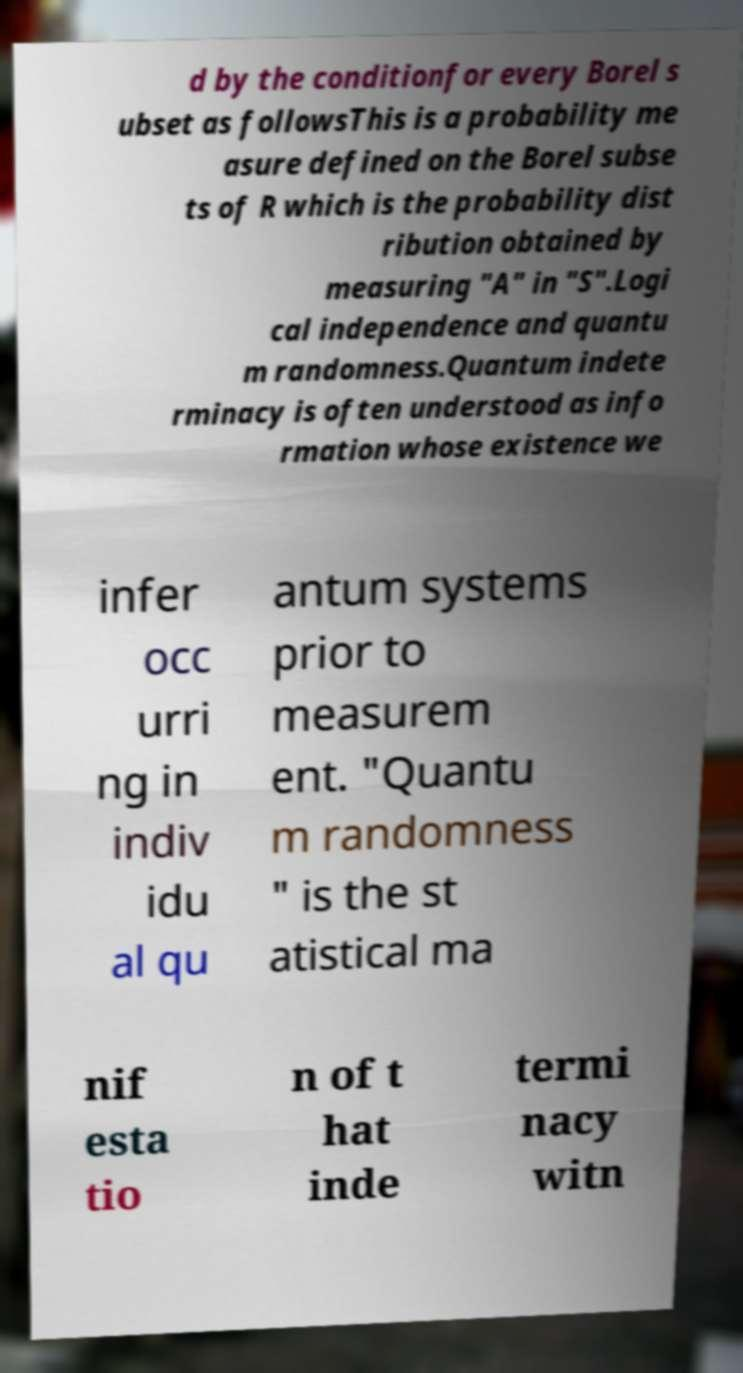Please read and relay the text visible in this image. What does it say? d by the conditionfor every Borel s ubset as followsThis is a probability me asure defined on the Borel subse ts of R which is the probability dist ribution obtained by measuring "A" in "S".Logi cal independence and quantu m randomness.Quantum indete rminacy is often understood as info rmation whose existence we infer occ urri ng in indiv idu al qu antum systems prior to measurem ent. "Quantu m randomness " is the st atistical ma nif esta tio n of t hat inde termi nacy witn 